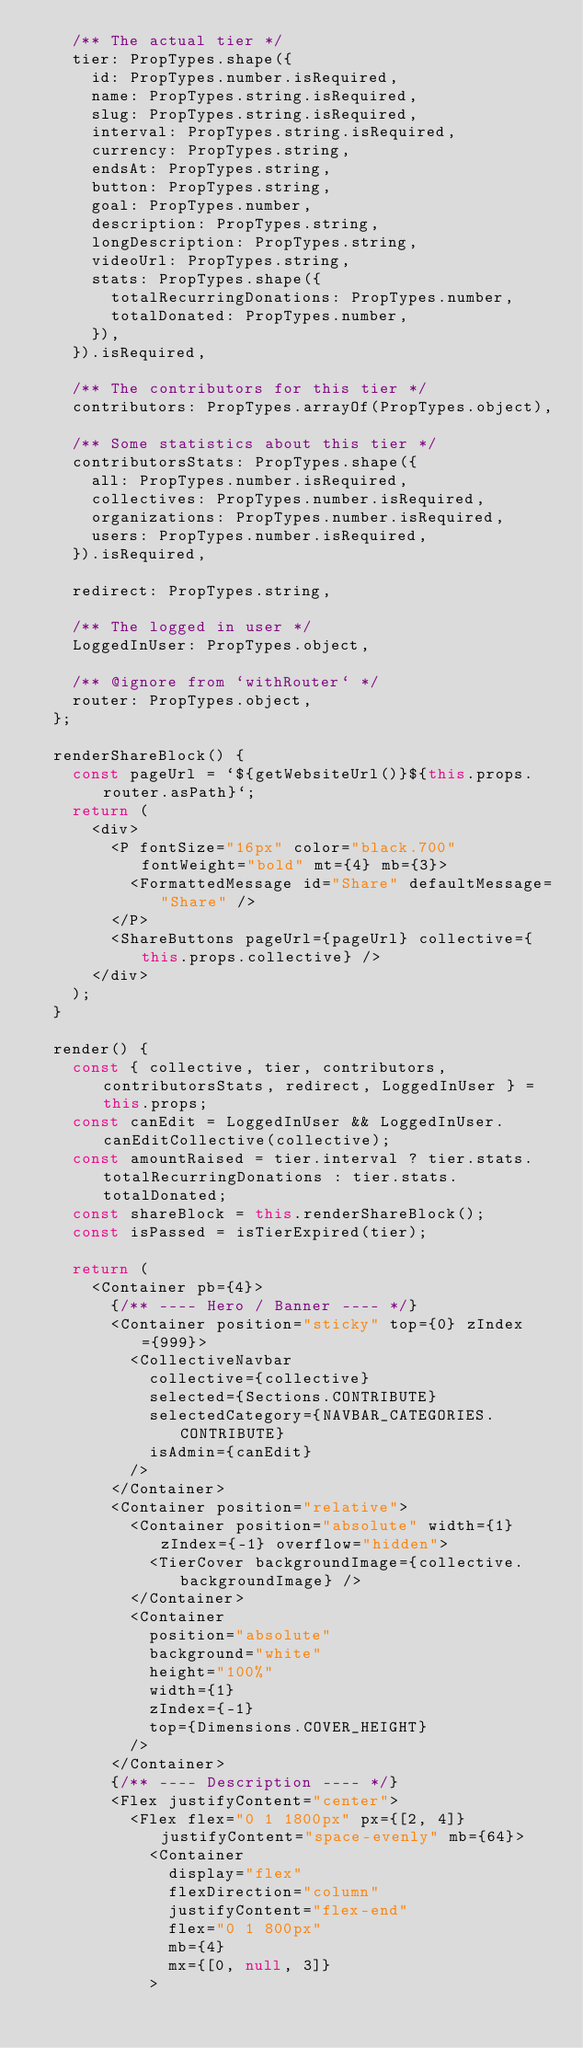<code> <loc_0><loc_0><loc_500><loc_500><_JavaScript_>    /** The actual tier */
    tier: PropTypes.shape({
      id: PropTypes.number.isRequired,
      name: PropTypes.string.isRequired,
      slug: PropTypes.string.isRequired,
      interval: PropTypes.string.isRequired,
      currency: PropTypes.string,
      endsAt: PropTypes.string,
      button: PropTypes.string,
      goal: PropTypes.number,
      description: PropTypes.string,
      longDescription: PropTypes.string,
      videoUrl: PropTypes.string,
      stats: PropTypes.shape({
        totalRecurringDonations: PropTypes.number,
        totalDonated: PropTypes.number,
      }),
    }).isRequired,

    /** The contributors for this tier */
    contributors: PropTypes.arrayOf(PropTypes.object),

    /** Some statistics about this tier */
    contributorsStats: PropTypes.shape({
      all: PropTypes.number.isRequired,
      collectives: PropTypes.number.isRequired,
      organizations: PropTypes.number.isRequired,
      users: PropTypes.number.isRequired,
    }).isRequired,

    redirect: PropTypes.string,

    /** The logged in user */
    LoggedInUser: PropTypes.object,

    /** @ignore from `withRouter` */
    router: PropTypes.object,
  };

  renderShareBlock() {
    const pageUrl = `${getWebsiteUrl()}${this.props.router.asPath}`;
    return (
      <div>
        <P fontSize="16px" color="black.700" fontWeight="bold" mt={4} mb={3}>
          <FormattedMessage id="Share" defaultMessage="Share" />
        </P>
        <ShareButtons pageUrl={pageUrl} collective={this.props.collective} />
      </div>
    );
  }

  render() {
    const { collective, tier, contributors, contributorsStats, redirect, LoggedInUser } = this.props;
    const canEdit = LoggedInUser && LoggedInUser.canEditCollective(collective);
    const amountRaised = tier.interval ? tier.stats.totalRecurringDonations : tier.stats.totalDonated;
    const shareBlock = this.renderShareBlock();
    const isPassed = isTierExpired(tier);

    return (
      <Container pb={4}>
        {/** ---- Hero / Banner ---- */}
        <Container position="sticky" top={0} zIndex={999}>
          <CollectiveNavbar
            collective={collective}
            selected={Sections.CONTRIBUTE}
            selectedCategory={NAVBAR_CATEGORIES.CONTRIBUTE}
            isAdmin={canEdit}
          />
        </Container>
        <Container position="relative">
          <Container position="absolute" width={1} zIndex={-1} overflow="hidden">
            <TierCover backgroundImage={collective.backgroundImage} />
          </Container>
          <Container
            position="absolute"
            background="white"
            height="100%"
            width={1}
            zIndex={-1}
            top={Dimensions.COVER_HEIGHT}
          />
        </Container>
        {/** ---- Description ---- */}
        <Flex justifyContent="center">
          <Flex flex="0 1 1800px" px={[2, 4]} justifyContent="space-evenly" mb={64}>
            <Container
              display="flex"
              flexDirection="column"
              justifyContent="flex-end"
              flex="0 1 800px"
              mb={4}
              mx={[0, null, 3]}
            ></code> 